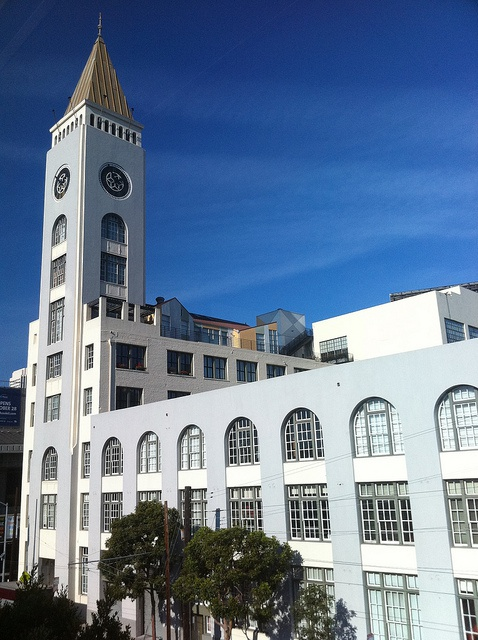Describe the objects in this image and their specific colors. I can see clock in navy, black, gray, and darkblue tones and clock in navy, black, gray, and darkgray tones in this image. 